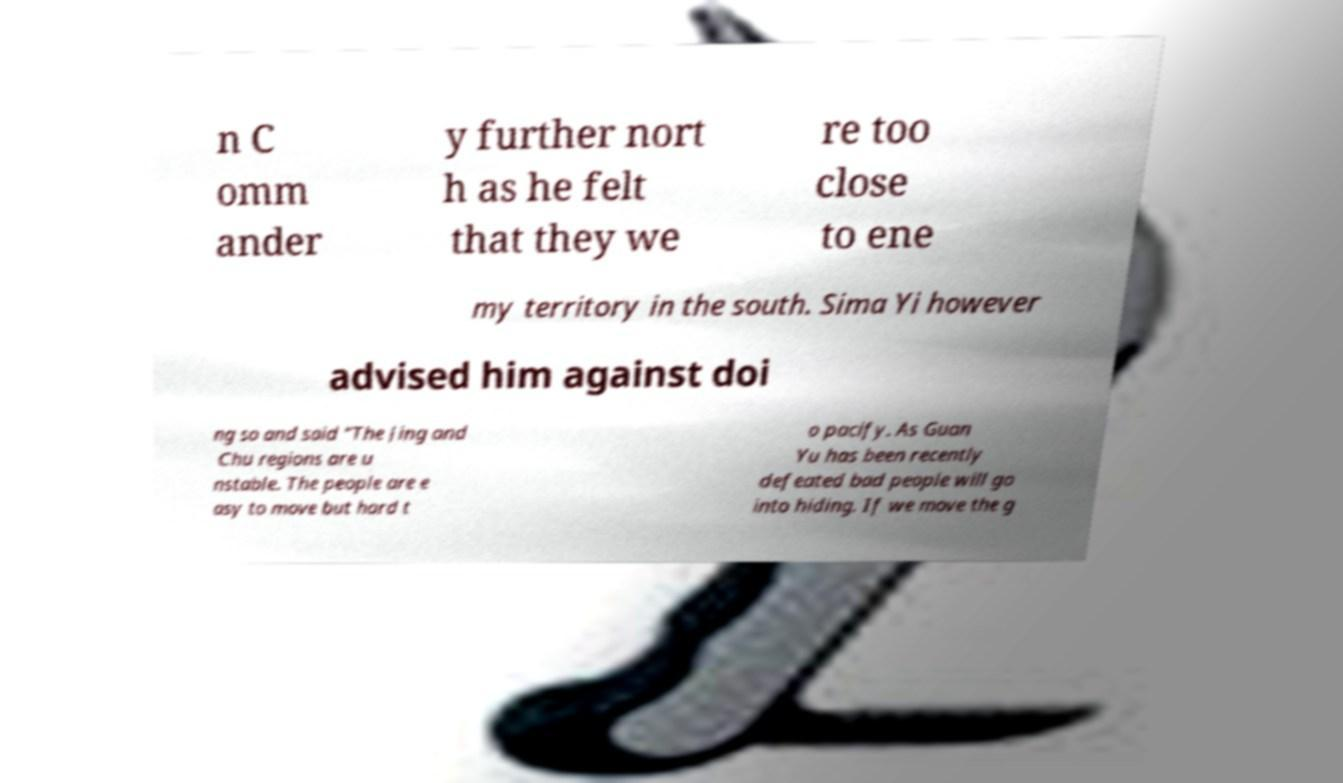Could you extract and type out the text from this image? n C omm ander y further nort h as he felt that they we re too close to ene my territory in the south. Sima Yi however advised him against doi ng so and said "The Jing and Chu regions are u nstable. The people are e asy to move but hard t o pacify. As Guan Yu has been recently defeated bad people will go into hiding. If we move the g 